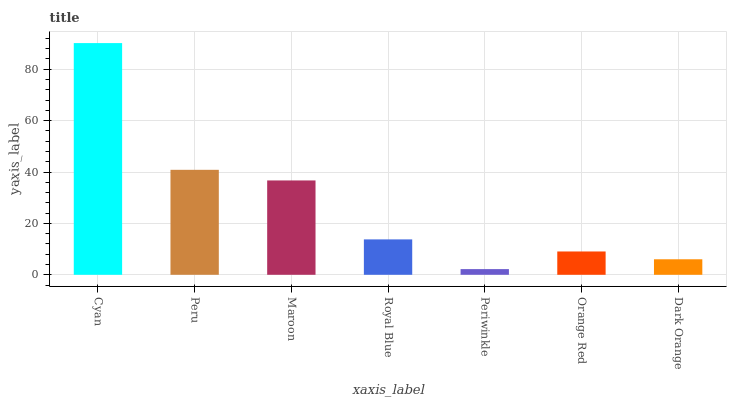Is Periwinkle the minimum?
Answer yes or no. Yes. Is Cyan the maximum?
Answer yes or no. Yes. Is Peru the minimum?
Answer yes or no. No. Is Peru the maximum?
Answer yes or no. No. Is Cyan greater than Peru?
Answer yes or no. Yes. Is Peru less than Cyan?
Answer yes or no. Yes. Is Peru greater than Cyan?
Answer yes or no. No. Is Cyan less than Peru?
Answer yes or no. No. Is Royal Blue the high median?
Answer yes or no. Yes. Is Royal Blue the low median?
Answer yes or no. Yes. Is Maroon the high median?
Answer yes or no. No. Is Periwinkle the low median?
Answer yes or no. No. 